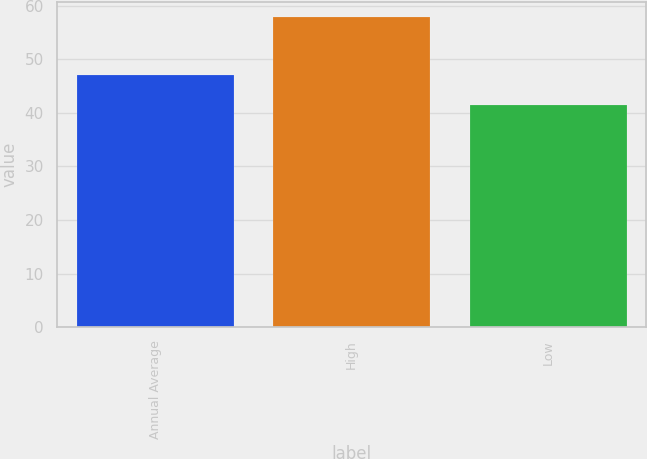<chart> <loc_0><loc_0><loc_500><loc_500><bar_chart><fcel>Annual Average<fcel>High<fcel>Low<nl><fcel>47.1<fcel>57.9<fcel>41.5<nl></chart> 